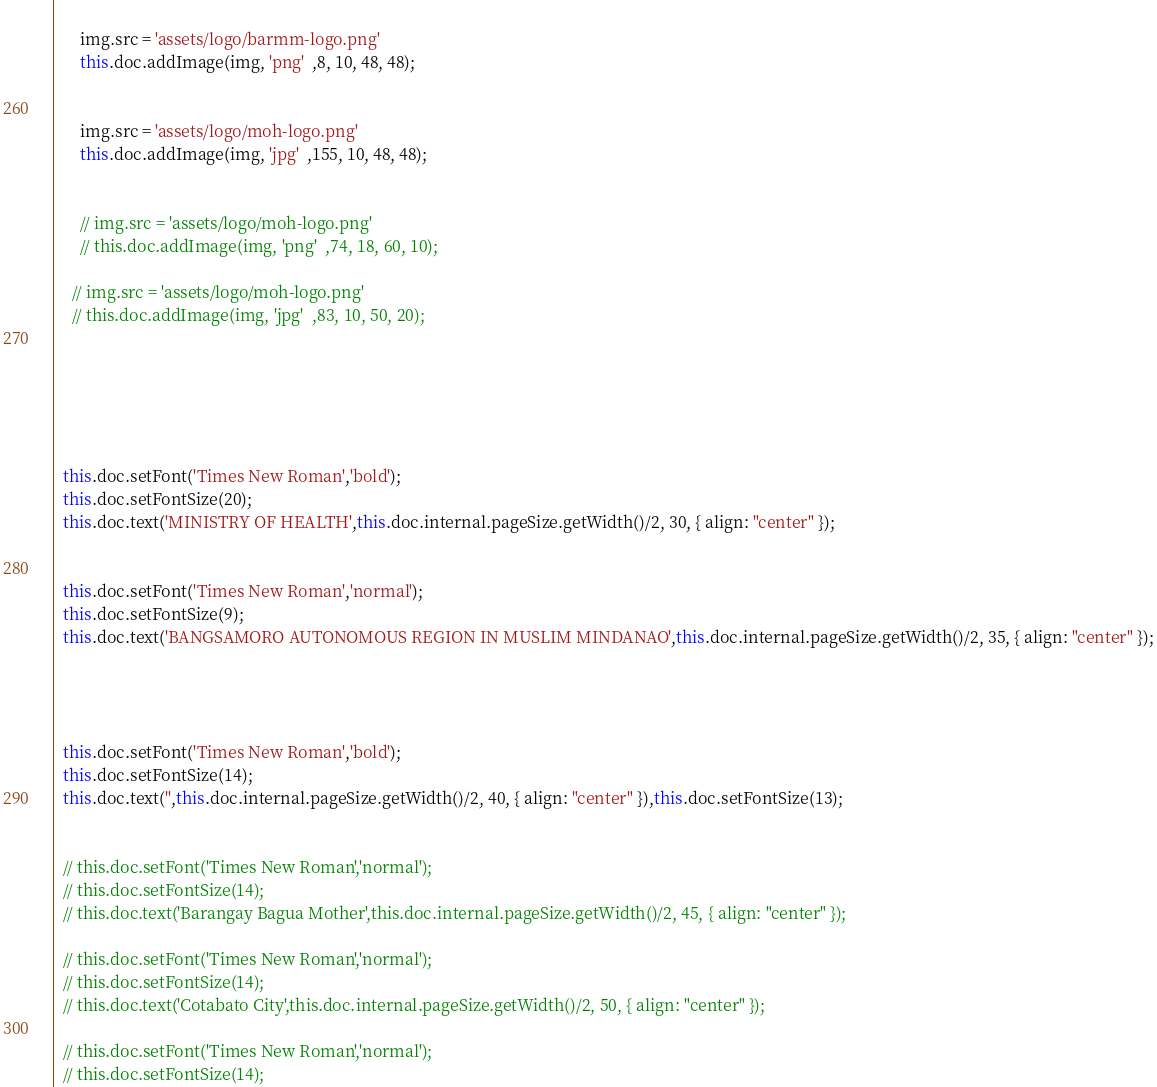<code> <loc_0><loc_0><loc_500><loc_500><_TypeScript_>  
      img.src = 'assets/logo/barmm-logo.png'
      this.doc.addImage(img, 'png'  ,8, 10, 48, 48);
  
  
      img.src = 'assets/logo/moh-logo.png'
      this.doc.addImage(img, 'jpg'  ,155, 10, 48, 48);
   
  
      // img.src = 'assets/logo/moh-logo.png'
      // this.doc.addImage(img, 'png'  ,74, 18, 60, 10);
  
    // img.src = 'assets/logo/moh-logo.png'
    // this.doc.addImage(img, 'jpg'  ,83, 10, 50, 20);
  
   
  
  
  
  
  this.doc.setFont('Times New Roman','bold');
  this.doc.setFontSize(20);
  this.doc.text('MINISTRY OF HEALTH',this.doc.internal.pageSize.getWidth()/2, 30, { align: "center" });
  
  
  this.doc.setFont('Times New Roman','normal');
  this.doc.setFontSize(9);
  this.doc.text('BANGSAMORO AUTONOMOUS REGION IN MUSLIM MINDANAO',this.doc.internal.pageSize.getWidth()/2, 35, { align: "center" });
  
  
  
  
  this.doc.setFont('Times New Roman','bold');
  this.doc.setFontSize(14);
  this.doc.text('',this.doc.internal.pageSize.getWidth()/2, 40, { align: "center" }),this.doc.setFontSize(13);
  
  
  // this.doc.setFont('Times New Roman','normal');
  // this.doc.setFontSize(14);
  // this.doc.text('Barangay Bagua Mother',this.doc.internal.pageSize.getWidth()/2, 45, { align: "center" });
  
  // this.doc.setFont('Times New Roman','normal');
  // this.doc.setFontSize(14);
  // this.doc.text('Cotabato City',this.doc.internal.pageSize.getWidth()/2, 50, { align: "center" });
  
  // this.doc.setFont('Times New Roman','normal');
  // this.doc.setFontSize(14);</code> 